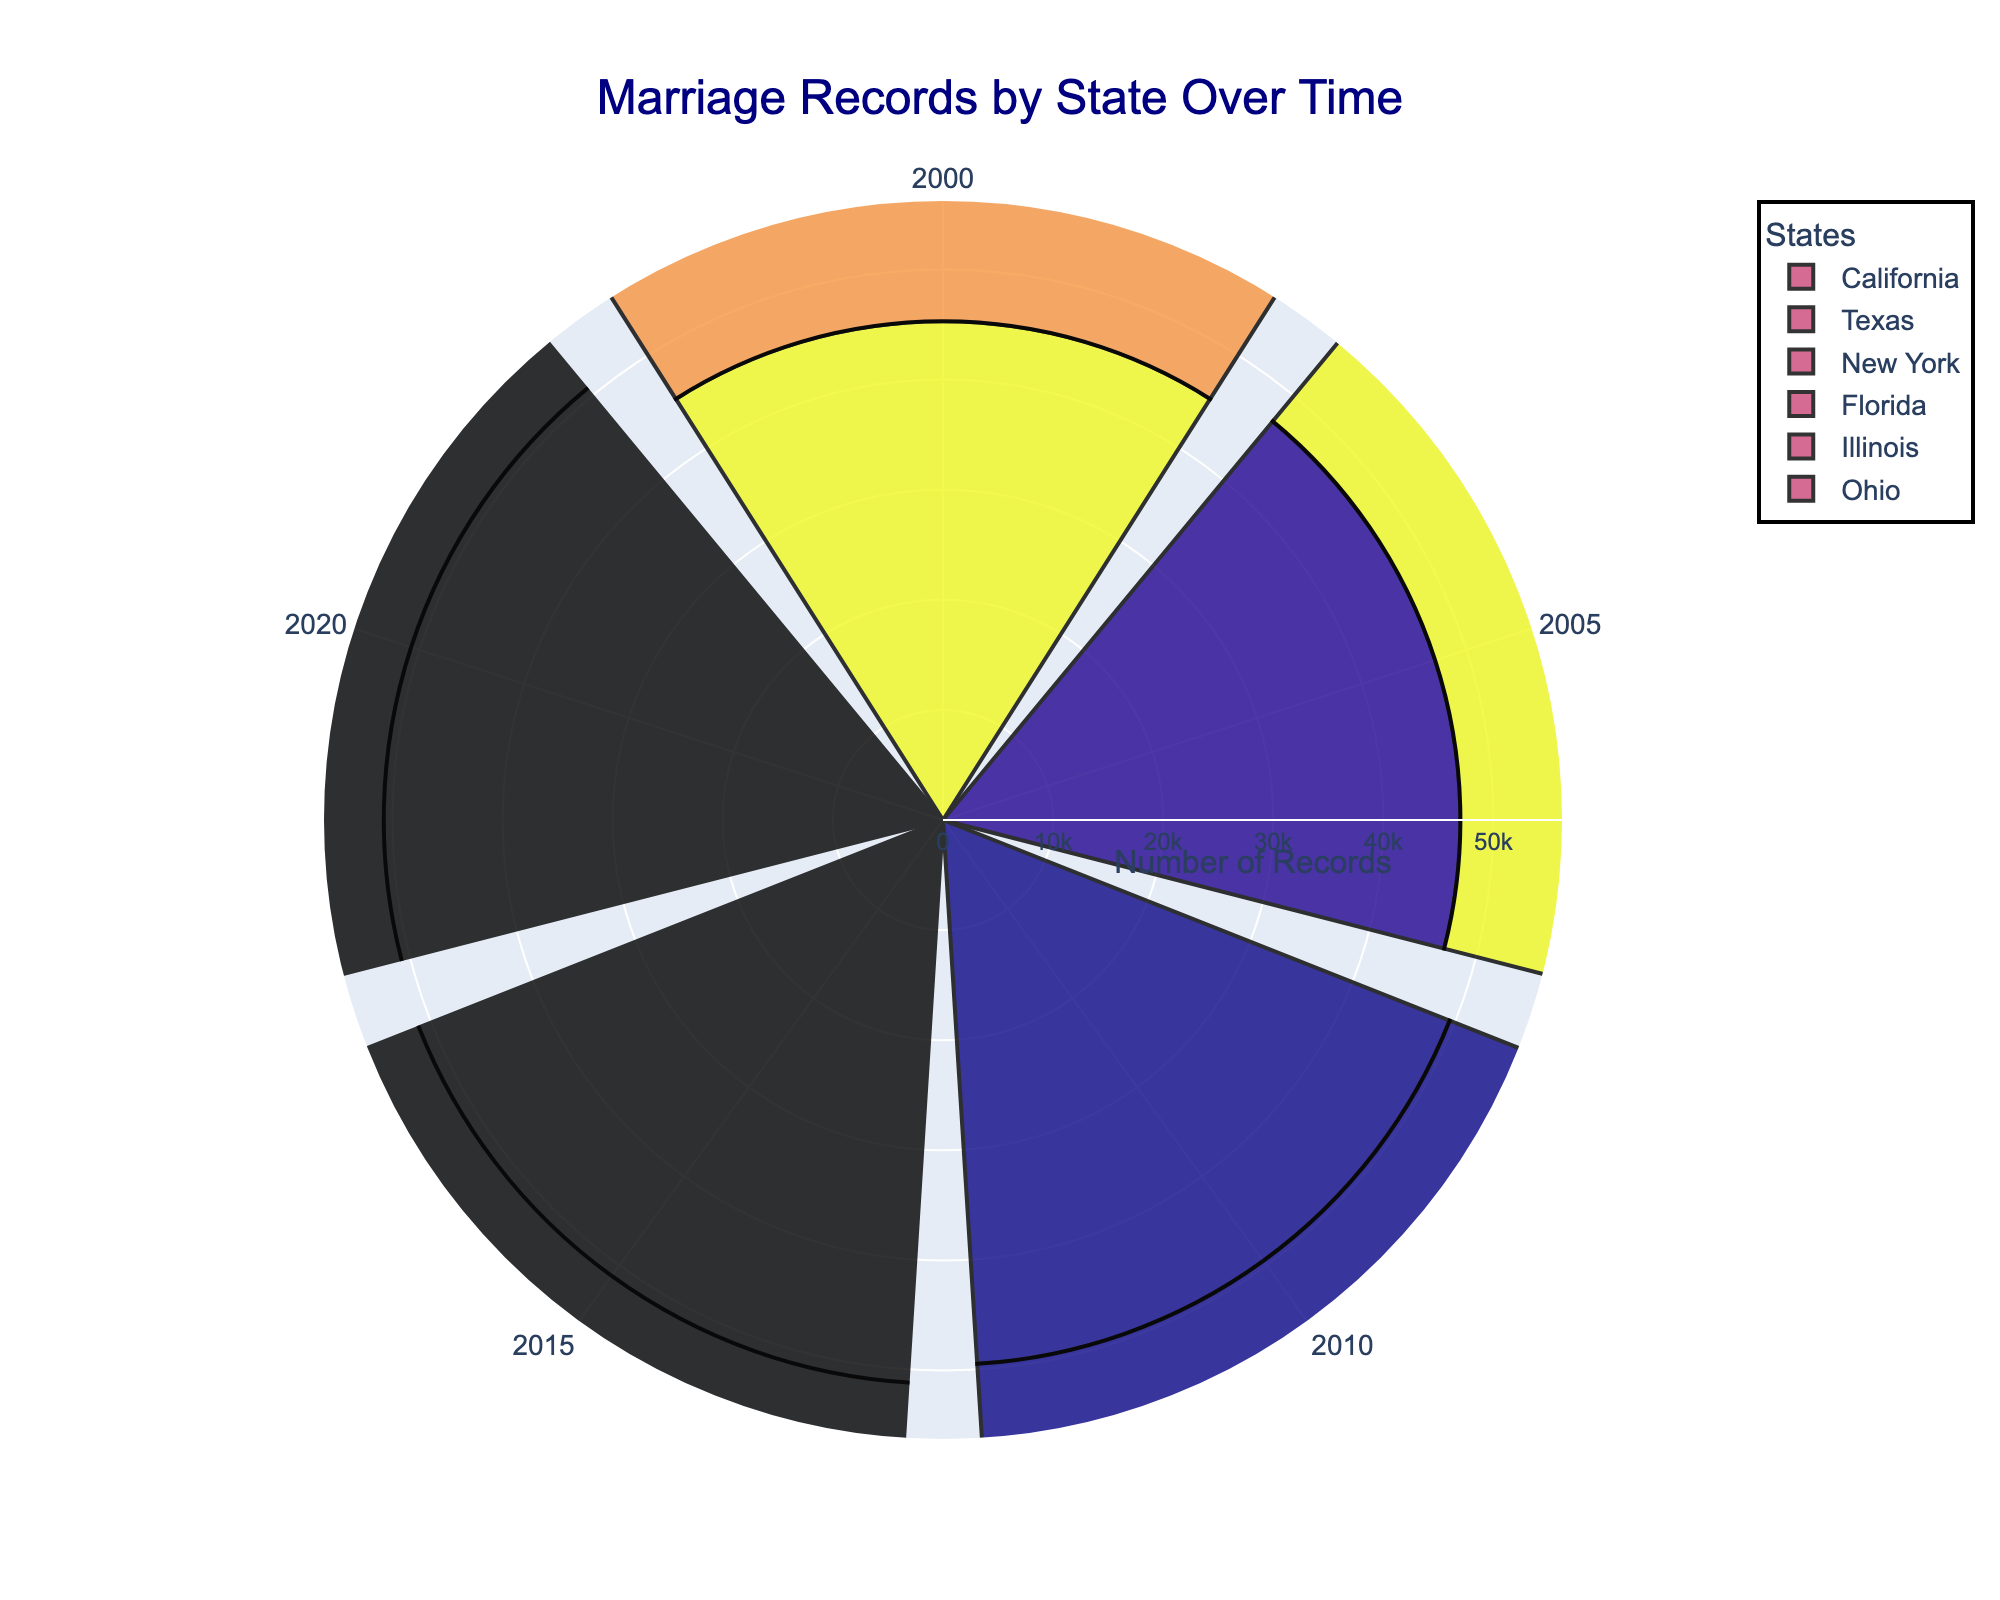What is the title of the figure? The title of the figure is displayed at the top within the figure and it often summarizes the main theme or purpose of the visual representation. By reading the title, one can understand what the data pertains to, indicating the thematic focus of the chart.
Answer: Marriage Records by State Over Time Which year has the highest number of marriage records for California? By looking at the bar lengths for California and identifying the longest bar, we can see which year corresponds to the maximum record. In the figure, this is typically marked with recognizable year labels.
Answer: 2015 What colors are used to represent each state? The colors are typically different for each state to help visually distinguish them. These might be shades that are randomly generated but each state's color remains consistent throughout its records.
Answer: Various (not specified in the explanation) How do the marriage records in Texas in 2010 compare to those in New York in 2010? By examining the heights of the bars corresponding to Texas and New York for the year 2010, one can visually compare them. If Texas has a taller bar than New York, it has more records and vice versa.
Answer: Texas has more records What is the general trend of marriage records in Florida from 2000 to 2020? Observing the progression of the bars for Florida over the given years helps identify the trend. An increasing height across the years will indicate an upward trend, whereas a decreasing height indicates a downward trend.
Answer: Increasing up to 2015, then slightly decreasing in 2020 Which state shows a decline in marriage records from 2015 to 2020? By comparing the bar heights for 2015 and 2020 for each state, we can detect which state shows a decline where the bar for 2020 is shorter than for 2015.
Answer: Illinois What is the range of marriage records in Ohio from 2000 to 2020? By identifying the highest and lowest bar heights for Ohio, we can calculate the range. The range is the difference between the maximum number and the minimum number of records.
Answer: 21500 to 23300 Which year had the second-highest marriage records for New York? We observe the length of the bars corresponding to each year for New York and identify which year has the second-longest bar.
Answer: 2015 What is the total number of marriage records for Texas from 2000 to 2020? Sum the bar heights (numbers of records) for all the years from 2000 to 2020 for Texas. Each bar represents the number of marriage records for a specific year in Texas.
Answer: 195,300 Among all the states, which state shows the most consistent number of marriage records over the years without much fluctuation? By examining the relative uniformity of the bar lengths across the years for each state, one can identify which state has the least variation in their record heights.
Answer: Ohio 